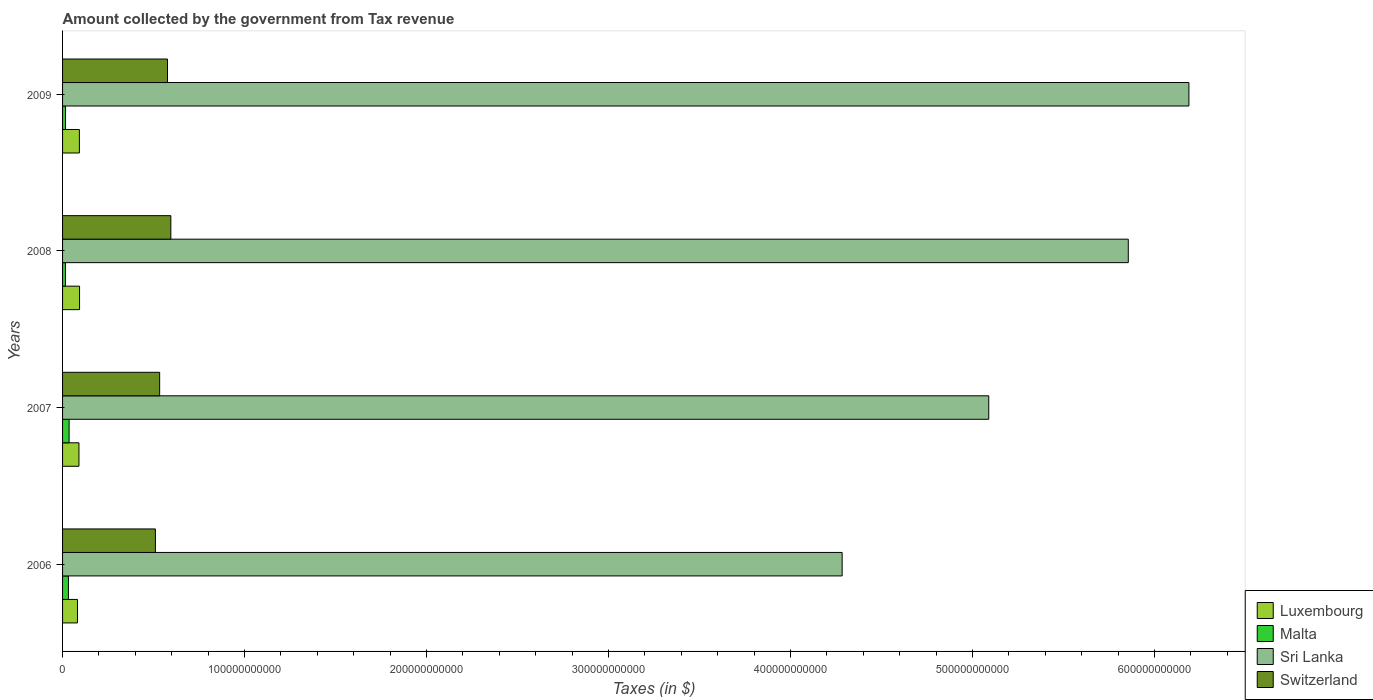How many different coloured bars are there?
Ensure brevity in your answer.  4. How many bars are there on the 4th tick from the bottom?
Ensure brevity in your answer.  4. What is the label of the 4th group of bars from the top?
Provide a succinct answer. 2006. In how many cases, is the number of bars for a given year not equal to the number of legend labels?
Your answer should be compact. 0. What is the amount collected by the government from tax revenue in Malta in 2008?
Offer a terse response. 1.59e+09. Across all years, what is the maximum amount collected by the government from tax revenue in Switzerland?
Your answer should be very brief. 5.95e+1. Across all years, what is the minimum amount collected by the government from tax revenue in Luxembourg?
Provide a short and direct response. 8.20e+09. In which year was the amount collected by the government from tax revenue in Malta maximum?
Your response must be concise. 2007. In which year was the amount collected by the government from tax revenue in Sri Lanka minimum?
Your response must be concise. 2006. What is the total amount collected by the government from tax revenue in Sri Lanka in the graph?
Give a very brief answer. 2.14e+12. What is the difference between the amount collected by the government from tax revenue in Switzerland in 2006 and that in 2009?
Offer a very short reply. -6.64e+09. What is the difference between the amount collected by the government from tax revenue in Luxembourg in 2006 and the amount collected by the government from tax revenue in Switzerland in 2009?
Offer a terse response. -4.95e+1. What is the average amount collected by the government from tax revenue in Malta per year?
Offer a very short reply. 2.51e+09. In the year 2008, what is the difference between the amount collected by the government from tax revenue in Sri Lanka and amount collected by the government from tax revenue in Luxembourg?
Make the answer very short. 5.76e+11. In how many years, is the amount collected by the government from tax revenue in Luxembourg greater than 100000000000 $?
Provide a succinct answer. 0. What is the ratio of the amount collected by the government from tax revenue in Switzerland in 2008 to that in 2009?
Keep it short and to the point. 1.03. Is the amount collected by the government from tax revenue in Switzerland in 2007 less than that in 2009?
Your response must be concise. Yes. What is the difference between the highest and the second highest amount collected by the government from tax revenue in Luxembourg?
Make the answer very short. 9.52e+07. What is the difference between the highest and the lowest amount collected by the government from tax revenue in Sri Lanka?
Offer a very short reply. 1.91e+11. In how many years, is the amount collected by the government from tax revenue in Switzerland greater than the average amount collected by the government from tax revenue in Switzerland taken over all years?
Provide a succinct answer. 2. What does the 3rd bar from the top in 2008 represents?
Give a very brief answer. Malta. What does the 1st bar from the bottom in 2006 represents?
Make the answer very short. Luxembourg. Is it the case that in every year, the sum of the amount collected by the government from tax revenue in Switzerland and amount collected by the government from tax revenue in Sri Lanka is greater than the amount collected by the government from tax revenue in Malta?
Make the answer very short. Yes. Are all the bars in the graph horizontal?
Keep it short and to the point. Yes. How many years are there in the graph?
Give a very brief answer. 4. What is the difference between two consecutive major ticks on the X-axis?
Your response must be concise. 1.00e+11. Where does the legend appear in the graph?
Your response must be concise. Bottom right. How many legend labels are there?
Make the answer very short. 4. What is the title of the graph?
Make the answer very short. Amount collected by the government from Tax revenue. Does "Malta" appear as one of the legend labels in the graph?
Give a very brief answer. Yes. What is the label or title of the X-axis?
Give a very brief answer. Taxes (in $). What is the Taxes (in $) in Luxembourg in 2006?
Give a very brief answer. 8.20e+09. What is the Taxes (in $) of Malta in 2006?
Provide a short and direct response. 3.22e+09. What is the Taxes (in $) of Sri Lanka in 2006?
Provide a short and direct response. 4.28e+11. What is the Taxes (in $) of Switzerland in 2006?
Your response must be concise. 5.10e+1. What is the Taxes (in $) of Luxembourg in 2007?
Give a very brief answer. 9.00e+09. What is the Taxes (in $) in Malta in 2007?
Your answer should be compact. 3.60e+09. What is the Taxes (in $) of Sri Lanka in 2007?
Ensure brevity in your answer.  5.09e+11. What is the Taxes (in $) of Switzerland in 2007?
Make the answer very short. 5.34e+1. What is the Taxes (in $) in Luxembourg in 2008?
Provide a succinct answer. 9.34e+09. What is the Taxes (in $) in Malta in 2008?
Provide a succinct answer. 1.59e+09. What is the Taxes (in $) in Sri Lanka in 2008?
Offer a very short reply. 5.86e+11. What is the Taxes (in $) in Switzerland in 2008?
Your answer should be compact. 5.95e+1. What is the Taxes (in $) of Luxembourg in 2009?
Your response must be concise. 9.25e+09. What is the Taxes (in $) in Malta in 2009?
Ensure brevity in your answer.  1.62e+09. What is the Taxes (in $) in Sri Lanka in 2009?
Your response must be concise. 6.19e+11. What is the Taxes (in $) of Switzerland in 2009?
Ensure brevity in your answer.  5.77e+1. Across all years, what is the maximum Taxes (in $) of Luxembourg?
Ensure brevity in your answer.  9.34e+09. Across all years, what is the maximum Taxes (in $) of Malta?
Give a very brief answer. 3.60e+09. Across all years, what is the maximum Taxes (in $) of Sri Lanka?
Offer a terse response. 6.19e+11. Across all years, what is the maximum Taxes (in $) in Switzerland?
Ensure brevity in your answer.  5.95e+1. Across all years, what is the minimum Taxes (in $) in Luxembourg?
Offer a very short reply. 8.20e+09. Across all years, what is the minimum Taxes (in $) in Malta?
Your answer should be compact. 1.59e+09. Across all years, what is the minimum Taxes (in $) of Sri Lanka?
Your response must be concise. 4.28e+11. Across all years, what is the minimum Taxes (in $) of Switzerland?
Your response must be concise. 5.10e+1. What is the total Taxes (in $) of Luxembourg in the graph?
Make the answer very short. 3.58e+1. What is the total Taxes (in $) in Malta in the graph?
Your answer should be very brief. 1.00e+1. What is the total Taxes (in $) of Sri Lanka in the graph?
Your response must be concise. 2.14e+12. What is the total Taxes (in $) of Switzerland in the graph?
Keep it short and to the point. 2.22e+11. What is the difference between the Taxes (in $) of Luxembourg in 2006 and that in 2007?
Make the answer very short. -8.05e+08. What is the difference between the Taxes (in $) in Malta in 2006 and that in 2007?
Offer a very short reply. -3.72e+08. What is the difference between the Taxes (in $) in Sri Lanka in 2006 and that in 2007?
Provide a short and direct response. -8.06e+1. What is the difference between the Taxes (in $) in Switzerland in 2006 and that in 2007?
Provide a succinct answer. -2.34e+09. What is the difference between the Taxes (in $) in Luxembourg in 2006 and that in 2008?
Your answer should be compact. -1.15e+09. What is the difference between the Taxes (in $) in Malta in 2006 and that in 2008?
Your answer should be compact. 1.63e+09. What is the difference between the Taxes (in $) in Sri Lanka in 2006 and that in 2008?
Ensure brevity in your answer.  -1.57e+11. What is the difference between the Taxes (in $) in Switzerland in 2006 and that in 2008?
Keep it short and to the point. -8.49e+09. What is the difference between the Taxes (in $) in Luxembourg in 2006 and that in 2009?
Make the answer very short. -1.05e+09. What is the difference between the Taxes (in $) in Malta in 2006 and that in 2009?
Give a very brief answer. 1.60e+09. What is the difference between the Taxes (in $) of Sri Lanka in 2006 and that in 2009?
Offer a very short reply. -1.91e+11. What is the difference between the Taxes (in $) of Switzerland in 2006 and that in 2009?
Your answer should be very brief. -6.64e+09. What is the difference between the Taxes (in $) in Luxembourg in 2007 and that in 2008?
Make the answer very short. -3.40e+08. What is the difference between the Taxes (in $) of Malta in 2007 and that in 2008?
Make the answer very short. 2.01e+09. What is the difference between the Taxes (in $) of Sri Lanka in 2007 and that in 2008?
Keep it short and to the point. -7.67e+1. What is the difference between the Taxes (in $) in Switzerland in 2007 and that in 2008?
Offer a very short reply. -6.15e+09. What is the difference between the Taxes (in $) in Luxembourg in 2007 and that in 2009?
Offer a very short reply. -2.45e+08. What is the difference between the Taxes (in $) of Malta in 2007 and that in 2009?
Provide a succinct answer. 1.97e+09. What is the difference between the Taxes (in $) of Sri Lanka in 2007 and that in 2009?
Give a very brief answer. -1.10e+11. What is the difference between the Taxes (in $) in Switzerland in 2007 and that in 2009?
Provide a succinct answer. -4.30e+09. What is the difference between the Taxes (in $) of Luxembourg in 2008 and that in 2009?
Ensure brevity in your answer.  9.52e+07. What is the difference between the Taxes (in $) of Malta in 2008 and that in 2009?
Your response must be concise. -3.38e+07. What is the difference between the Taxes (in $) of Sri Lanka in 2008 and that in 2009?
Provide a short and direct response. -3.33e+1. What is the difference between the Taxes (in $) of Switzerland in 2008 and that in 2009?
Ensure brevity in your answer.  1.85e+09. What is the difference between the Taxes (in $) of Luxembourg in 2006 and the Taxes (in $) of Malta in 2007?
Keep it short and to the point. 4.60e+09. What is the difference between the Taxes (in $) of Luxembourg in 2006 and the Taxes (in $) of Sri Lanka in 2007?
Provide a short and direct response. -5.01e+11. What is the difference between the Taxes (in $) of Luxembourg in 2006 and the Taxes (in $) of Switzerland in 2007?
Make the answer very short. -4.52e+1. What is the difference between the Taxes (in $) of Malta in 2006 and the Taxes (in $) of Sri Lanka in 2007?
Your answer should be compact. -5.06e+11. What is the difference between the Taxes (in $) of Malta in 2006 and the Taxes (in $) of Switzerland in 2007?
Keep it short and to the point. -5.01e+1. What is the difference between the Taxes (in $) in Sri Lanka in 2006 and the Taxes (in $) in Switzerland in 2007?
Give a very brief answer. 3.75e+11. What is the difference between the Taxes (in $) of Luxembourg in 2006 and the Taxes (in $) of Malta in 2008?
Your response must be concise. 6.61e+09. What is the difference between the Taxes (in $) of Luxembourg in 2006 and the Taxes (in $) of Sri Lanka in 2008?
Ensure brevity in your answer.  -5.77e+11. What is the difference between the Taxes (in $) in Luxembourg in 2006 and the Taxes (in $) in Switzerland in 2008?
Provide a short and direct response. -5.13e+1. What is the difference between the Taxes (in $) of Malta in 2006 and the Taxes (in $) of Sri Lanka in 2008?
Your answer should be very brief. -5.82e+11. What is the difference between the Taxes (in $) in Malta in 2006 and the Taxes (in $) in Switzerland in 2008?
Offer a terse response. -5.63e+1. What is the difference between the Taxes (in $) of Sri Lanka in 2006 and the Taxes (in $) of Switzerland in 2008?
Make the answer very short. 3.69e+11. What is the difference between the Taxes (in $) of Luxembourg in 2006 and the Taxes (in $) of Malta in 2009?
Make the answer very short. 6.57e+09. What is the difference between the Taxes (in $) of Luxembourg in 2006 and the Taxes (in $) of Sri Lanka in 2009?
Your answer should be very brief. -6.11e+11. What is the difference between the Taxes (in $) in Luxembourg in 2006 and the Taxes (in $) in Switzerland in 2009?
Provide a succinct answer. -4.95e+1. What is the difference between the Taxes (in $) in Malta in 2006 and the Taxes (in $) in Sri Lanka in 2009?
Offer a very short reply. -6.16e+11. What is the difference between the Taxes (in $) in Malta in 2006 and the Taxes (in $) in Switzerland in 2009?
Provide a short and direct response. -5.44e+1. What is the difference between the Taxes (in $) in Sri Lanka in 2006 and the Taxes (in $) in Switzerland in 2009?
Offer a terse response. 3.71e+11. What is the difference between the Taxes (in $) in Luxembourg in 2007 and the Taxes (in $) in Malta in 2008?
Provide a succinct answer. 7.41e+09. What is the difference between the Taxes (in $) of Luxembourg in 2007 and the Taxes (in $) of Sri Lanka in 2008?
Offer a terse response. -5.77e+11. What is the difference between the Taxes (in $) in Luxembourg in 2007 and the Taxes (in $) in Switzerland in 2008?
Make the answer very short. -5.05e+1. What is the difference between the Taxes (in $) of Malta in 2007 and the Taxes (in $) of Sri Lanka in 2008?
Provide a succinct answer. -5.82e+11. What is the difference between the Taxes (in $) of Malta in 2007 and the Taxes (in $) of Switzerland in 2008?
Offer a terse response. -5.59e+1. What is the difference between the Taxes (in $) in Sri Lanka in 2007 and the Taxes (in $) in Switzerland in 2008?
Give a very brief answer. 4.49e+11. What is the difference between the Taxes (in $) in Luxembourg in 2007 and the Taxes (in $) in Malta in 2009?
Keep it short and to the point. 7.38e+09. What is the difference between the Taxes (in $) of Luxembourg in 2007 and the Taxes (in $) of Sri Lanka in 2009?
Provide a short and direct response. -6.10e+11. What is the difference between the Taxes (in $) of Luxembourg in 2007 and the Taxes (in $) of Switzerland in 2009?
Provide a short and direct response. -4.86e+1. What is the difference between the Taxes (in $) of Malta in 2007 and the Taxes (in $) of Sri Lanka in 2009?
Provide a short and direct response. -6.15e+11. What is the difference between the Taxes (in $) of Malta in 2007 and the Taxes (in $) of Switzerland in 2009?
Your response must be concise. -5.41e+1. What is the difference between the Taxes (in $) in Sri Lanka in 2007 and the Taxes (in $) in Switzerland in 2009?
Your answer should be very brief. 4.51e+11. What is the difference between the Taxes (in $) in Luxembourg in 2008 and the Taxes (in $) in Malta in 2009?
Your answer should be very brief. 7.72e+09. What is the difference between the Taxes (in $) in Luxembourg in 2008 and the Taxes (in $) in Sri Lanka in 2009?
Provide a succinct answer. -6.10e+11. What is the difference between the Taxes (in $) of Luxembourg in 2008 and the Taxes (in $) of Switzerland in 2009?
Offer a terse response. -4.83e+1. What is the difference between the Taxes (in $) in Malta in 2008 and the Taxes (in $) in Sri Lanka in 2009?
Keep it short and to the point. -6.17e+11. What is the difference between the Taxes (in $) of Malta in 2008 and the Taxes (in $) of Switzerland in 2009?
Provide a short and direct response. -5.61e+1. What is the difference between the Taxes (in $) in Sri Lanka in 2008 and the Taxes (in $) in Switzerland in 2009?
Make the answer very short. 5.28e+11. What is the average Taxes (in $) of Luxembourg per year?
Ensure brevity in your answer.  8.95e+09. What is the average Taxes (in $) of Malta per year?
Give a very brief answer. 2.51e+09. What is the average Taxes (in $) of Sri Lanka per year?
Ensure brevity in your answer.  5.35e+11. What is the average Taxes (in $) of Switzerland per year?
Ensure brevity in your answer.  5.54e+1. In the year 2006, what is the difference between the Taxes (in $) of Luxembourg and Taxes (in $) of Malta?
Give a very brief answer. 4.97e+09. In the year 2006, what is the difference between the Taxes (in $) in Luxembourg and Taxes (in $) in Sri Lanka?
Your response must be concise. -4.20e+11. In the year 2006, what is the difference between the Taxes (in $) in Luxembourg and Taxes (in $) in Switzerland?
Offer a terse response. -4.28e+1. In the year 2006, what is the difference between the Taxes (in $) of Malta and Taxes (in $) of Sri Lanka?
Your response must be concise. -4.25e+11. In the year 2006, what is the difference between the Taxes (in $) of Malta and Taxes (in $) of Switzerland?
Your answer should be compact. -4.78e+1. In the year 2006, what is the difference between the Taxes (in $) of Sri Lanka and Taxes (in $) of Switzerland?
Your answer should be compact. 3.77e+11. In the year 2007, what is the difference between the Taxes (in $) of Luxembourg and Taxes (in $) of Malta?
Offer a very short reply. 5.41e+09. In the year 2007, what is the difference between the Taxes (in $) of Luxembourg and Taxes (in $) of Sri Lanka?
Make the answer very short. -5.00e+11. In the year 2007, what is the difference between the Taxes (in $) in Luxembourg and Taxes (in $) in Switzerland?
Make the answer very short. -4.43e+1. In the year 2007, what is the difference between the Taxes (in $) of Malta and Taxes (in $) of Sri Lanka?
Offer a very short reply. -5.05e+11. In the year 2007, what is the difference between the Taxes (in $) in Malta and Taxes (in $) in Switzerland?
Make the answer very short. -4.98e+1. In the year 2007, what is the difference between the Taxes (in $) in Sri Lanka and Taxes (in $) in Switzerland?
Your answer should be compact. 4.56e+11. In the year 2008, what is the difference between the Taxes (in $) of Luxembourg and Taxes (in $) of Malta?
Offer a very short reply. 7.75e+09. In the year 2008, what is the difference between the Taxes (in $) of Luxembourg and Taxes (in $) of Sri Lanka?
Provide a succinct answer. -5.76e+11. In the year 2008, what is the difference between the Taxes (in $) of Luxembourg and Taxes (in $) of Switzerland?
Keep it short and to the point. -5.02e+1. In the year 2008, what is the difference between the Taxes (in $) of Malta and Taxes (in $) of Sri Lanka?
Offer a terse response. -5.84e+11. In the year 2008, what is the difference between the Taxes (in $) in Malta and Taxes (in $) in Switzerland?
Your answer should be compact. -5.79e+1. In the year 2008, what is the difference between the Taxes (in $) of Sri Lanka and Taxes (in $) of Switzerland?
Provide a short and direct response. 5.26e+11. In the year 2009, what is the difference between the Taxes (in $) in Luxembourg and Taxes (in $) in Malta?
Give a very brief answer. 7.62e+09. In the year 2009, what is the difference between the Taxes (in $) of Luxembourg and Taxes (in $) of Sri Lanka?
Provide a succinct answer. -6.10e+11. In the year 2009, what is the difference between the Taxes (in $) of Luxembourg and Taxes (in $) of Switzerland?
Give a very brief answer. -4.84e+1. In the year 2009, what is the difference between the Taxes (in $) of Malta and Taxes (in $) of Sri Lanka?
Your response must be concise. -6.17e+11. In the year 2009, what is the difference between the Taxes (in $) of Malta and Taxes (in $) of Switzerland?
Offer a very short reply. -5.60e+1. In the year 2009, what is the difference between the Taxes (in $) of Sri Lanka and Taxes (in $) of Switzerland?
Your answer should be compact. 5.61e+11. What is the ratio of the Taxes (in $) in Luxembourg in 2006 to that in 2007?
Provide a short and direct response. 0.91. What is the ratio of the Taxes (in $) in Malta in 2006 to that in 2007?
Offer a very short reply. 0.9. What is the ratio of the Taxes (in $) in Sri Lanka in 2006 to that in 2007?
Offer a terse response. 0.84. What is the ratio of the Taxes (in $) in Switzerland in 2006 to that in 2007?
Ensure brevity in your answer.  0.96. What is the ratio of the Taxes (in $) in Luxembourg in 2006 to that in 2008?
Your answer should be very brief. 0.88. What is the ratio of the Taxes (in $) of Malta in 2006 to that in 2008?
Your response must be concise. 2.03. What is the ratio of the Taxes (in $) of Sri Lanka in 2006 to that in 2008?
Offer a very short reply. 0.73. What is the ratio of the Taxes (in $) in Switzerland in 2006 to that in 2008?
Provide a succinct answer. 0.86. What is the ratio of the Taxes (in $) in Luxembourg in 2006 to that in 2009?
Provide a short and direct response. 0.89. What is the ratio of the Taxes (in $) in Malta in 2006 to that in 2009?
Offer a very short reply. 1.99. What is the ratio of the Taxes (in $) of Sri Lanka in 2006 to that in 2009?
Your response must be concise. 0.69. What is the ratio of the Taxes (in $) of Switzerland in 2006 to that in 2009?
Your response must be concise. 0.88. What is the ratio of the Taxes (in $) in Luxembourg in 2007 to that in 2008?
Provide a succinct answer. 0.96. What is the ratio of the Taxes (in $) in Malta in 2007 to that in 2008?
Give a very brief answer. 2.26. What is the ratio of the Taxes (in $) of Sri Lanka in 2007 to that in 2008?
Offer a very short reply. 0.87. What is the ratio of the Taxes (in $) in Switzerland in 2007 to that in 2008?
Your answer should be compact. 0.9. What is the ratio of the Taxes (in $) in Luxembourg in 2007 to that in 2009?
Your answer should be compact. 0.97. What is the ratio of the Taxes (in $) in Malta in 2007 to that in 2009?
Your response must be concise. 2.22. What is the ratio of the Taxes (in $) of Sri Lanka in 2007 to that in 2009?
Give a very brief answer. 0.82. What is the ratio of the Taxes (in $) in Switzerland in 2007 to that in 2009?
Provide a short and direct response. 0.93. What is the ratio of the Taxes (in $) of Luxembourg in 2008 to that in 2009?
Give a very brief answer. 1.01. What is the ratio of the Taxes (in $) in Malta in 2008 to that in 2009?
Give a very brief answer. 0.98. What is the ratio of the Taxes (in $) of Sri Lanka in 2008 to that in 2009?
Your answer should be very brief. 0.95. What is the ratio of the Taxes (in $) of Switzerland in 2008 to that in 2009?
Provide a short and direct response. 1.03. What is the difference between the highest and the second highest Taxes (in $) in Luxembourg?
Your answer should be compact. 9.52e+07. What is the difference between the highest and the second highest Taxes (in $) of Malta?
Offer a very short reply. 3.72e+08. What is the difference between the highest and the second highest Taxes (in $) in Sri Lanka?
Provide a succinct answer. 3.33e+1. What is the difference between the highest and the second highest Taxes (in $) in Switzerland?
Your answer should be compact. 1.85e+09. What is the difference between the highest and the lowest Taxes (in $) of Luxembourg?
Give a very brief answer. 1.15e+09. What is the difference between the highest and the lowest Taxes (in $) in Malta?
Offer a very short reply. 2.01e+09. What is the difference between the highest and the lowest Taxes (in $) in Sri Lanka?
Ensure brevity in your answer.  1.91e+11. What is the difference between the highest and the lowest Taxes (in $) of Switzerland?
Make the answer very short. 8.49e+09. 